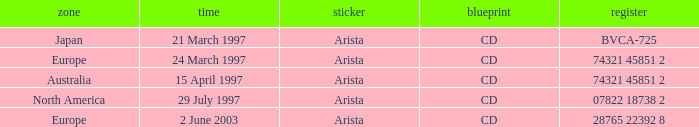Help me parse the entirety of this table. {'header': ['zone', 'time', 'sticker', 'blueprint', 'register'], 'rows': [['Japan', '21 March 1997', 'Arista', 'CD', 'BVCA-725'], ['Europe', '24 March 1997', 'Arista', 'CD', '74321 45851 2'], ['Australia', '15 April 1997', 'Arista', 'CD', '74321 45851 2'], ['North America', '29 July 1997', 'Arista', 'CD', '07822 18738 2'], ['Europe', '2 June 2003', 'Arista', 'CD', '28765 22392 8']]} On which date does the european region have a catalog of 74321 45851 2? 24 March 1997. 